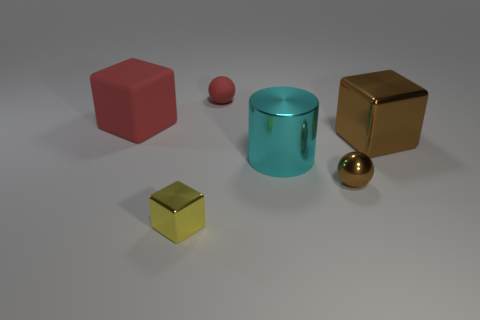Subtract all red balls. How many balls are left? 1 Subtract all red cubes. How many cubes are left? 2 Subtract all gray blocks. How many brown spheres are left? 1 Subtract 0 purple spheres. How many objects are left? 6 Subtract all cylinders. How many objects are left? 5 Subtract 2 balls. How many balls are left? 0 Subtract all brown cylinders. Subtract all red balls. How many cylinders are left? 1 Subtract all cyan rubber cubes. Subtract all brown blocks. How many objects are left? 5 Add 2 large red matte cubes. How many large red matte cubes are left? 3 Add 4 brown matte things. How many brown matte things exist? 4 